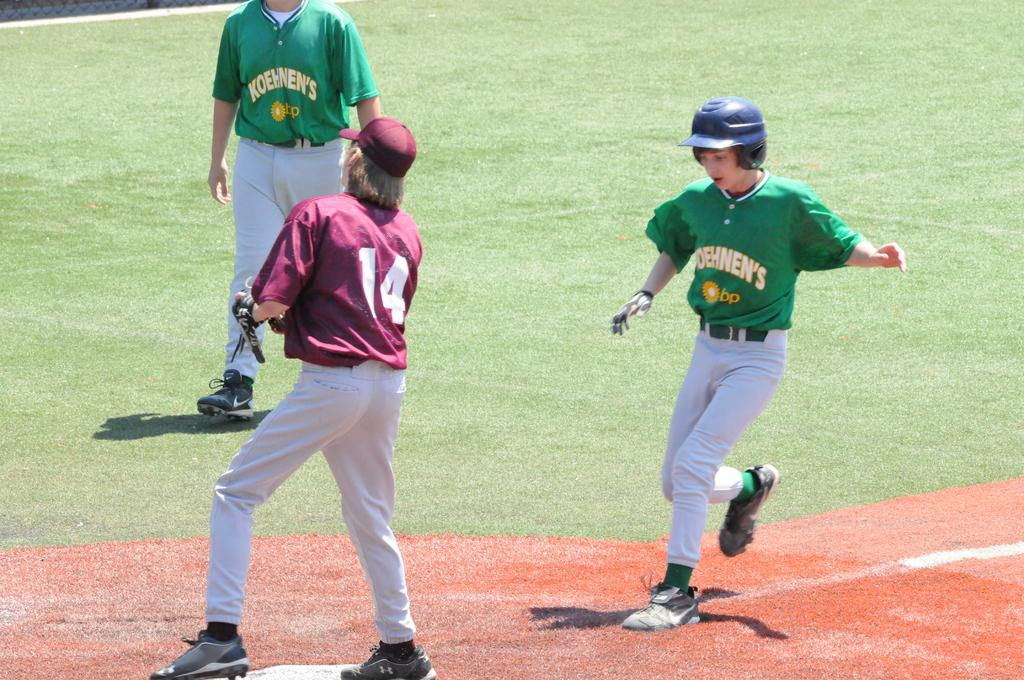<image>
Write a terse but informative summary of the picture. A baseball team for younger boys called the Koehnen's, endorsed by BP, are playing baseball. 